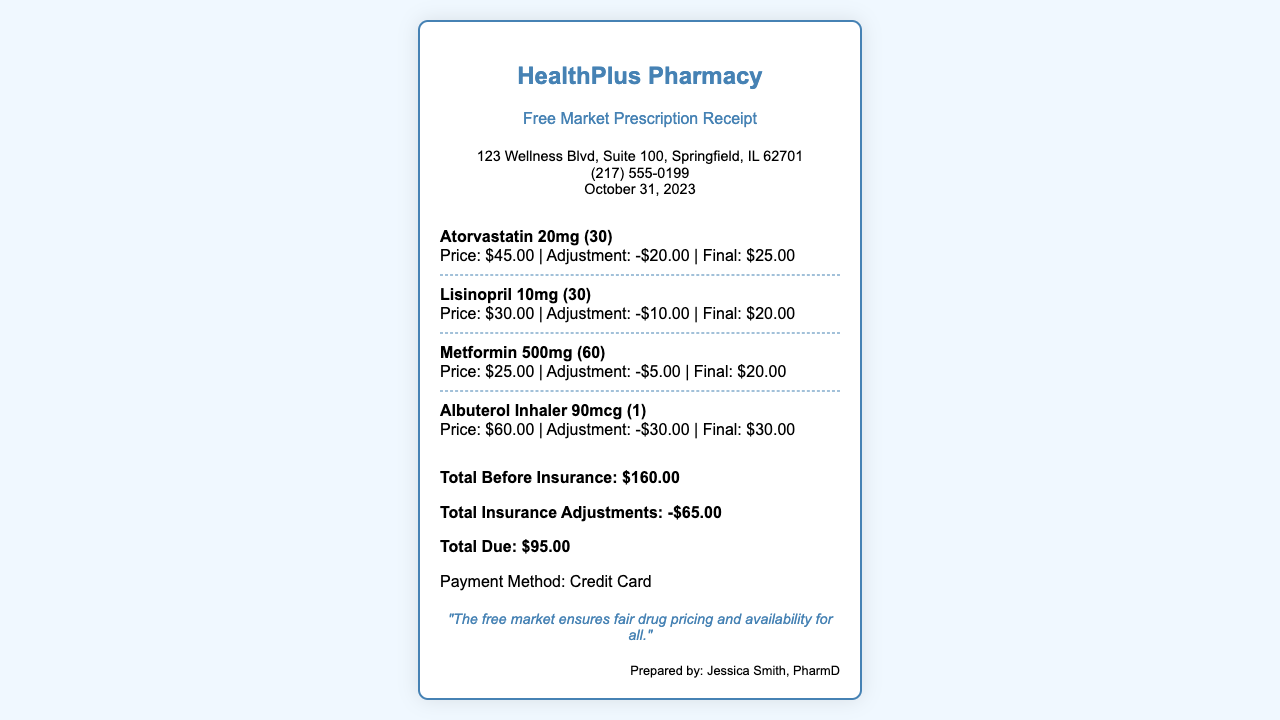What is the name of the pharmacy? The pharmacy's name is stated at the top of the receipt.
Answer: HealthPlus Pharmacy What date is the receipt issued? The date is provided in the pharmacy info section.
Answer: October 31, 2023 How much was the original price of Atorvastatin? The original price is listed next to the item name.
Answer: $45.00 What is the total due after insurance adjustments? The total due is the final amount calculated after adjustments.
Answer: $95.00 Who prepared the receipt? The name of the person who prepared the receipt is mentioned at the bottom.
Answer: Jessica Smith, PharmD What is the adjustment amount for Albuterol Inhaler? The adjustment amount is specifically noted next to the drug.
Answer: -$30.00 How many Lisinopril tablets are included? The quantity is mentioned next to the drug's dosage.
Answer: 30 What is the total before insurance? The total before insurance is provided in the totals section.
Answer: $160.00 What is one argument in favor of the free market mentioned on the receipt? A quote is provided that reflects the benefits of a free market.
Answer: "The free market ensures fair drug pricing and availability for all." 